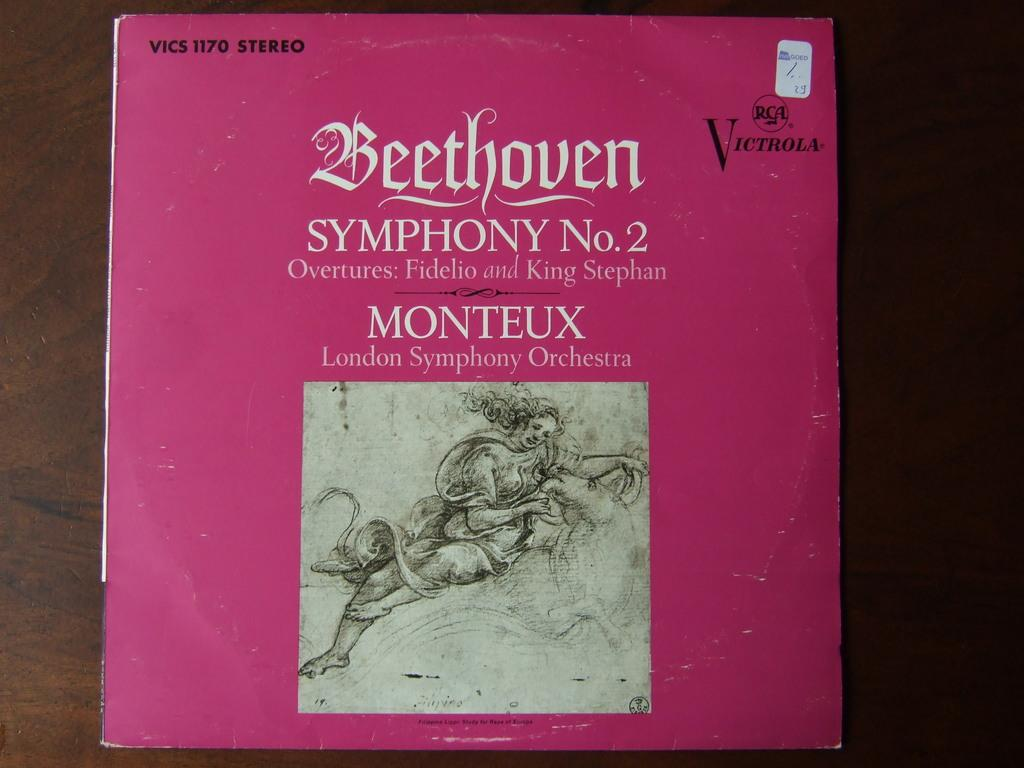<image>
Share a concise interpretation of the image provided. A vinyl record of Beethoven Symphony No. 2 Overtures: Fidelio and King Stephan 